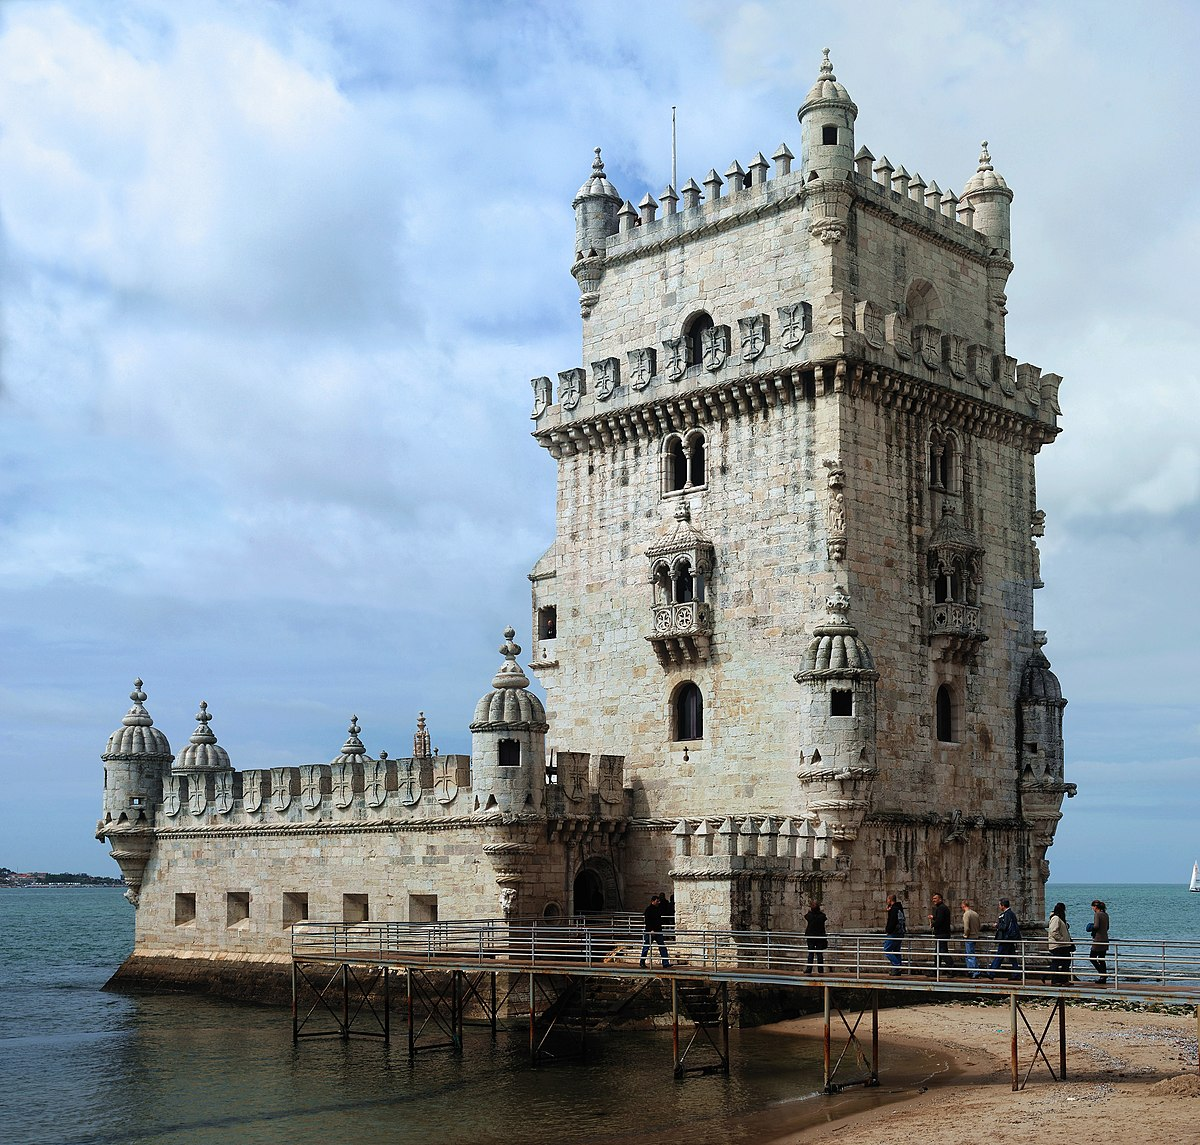Write a detailed description of the given image.
 The image captures the majestic Torre De Belem, also known as Belem Tower, standing tall in Lisbon, Portugal. This fortified tower, a UNESCO World Heritage Site, is a striking example of the Portuguese Manueline style. The tower is constructed from white stone, giving it a pristine appearance that contrasts beautifully with the surrounding water and sky.

The tower's square base is sturdy and robust, with four turrets adorning the corners. These turrets add a sense of grandeur and fortitude to the structure. The top of the tower is embellished with battlements and ornate carvings, showcasing the intricate craftsmanship of the Manueline style.

The tower is surrounded by water on three sides, creating a serene and tranquil atmosphere. A wooden walkway leads up to the tower, inviting visitors to explore its historical depths. A few people can be seen on the walkway and around the base of the tower, adding a touch of life to the scene.

The perspective of the photo is from a distance, allowing the entire tower and its surroundings to be captured in the frame. This gives viewers a comprehensive view of the landmark and its setting. The colors in the image are natural and vibrant, with the white of the tower, the blue of the water and sky, and the brown of the walkway creating a harmonious palette.

Overall, the image provides a detailed and vivid depiction of the Belem Tower, highlighting its architectural beauty and historical significance. It's a snapshot of a moment in time at this renowned worldwide landmark. 